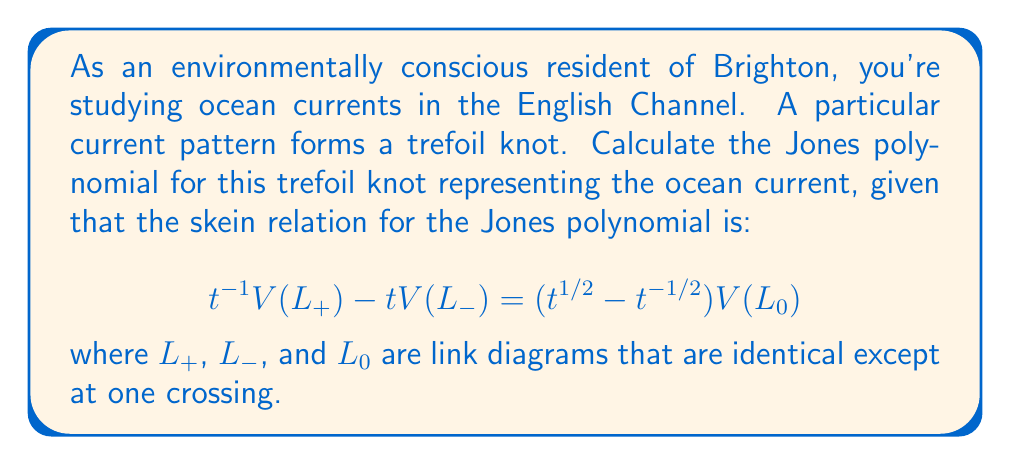What is the answer to this math problem? Let's calculate the Jones polynomial for the trefoil knot step-by-step:

1) First, we need to orient the trefoil knot. Let's consider the right-handed trefoil.

2) We'll use the skein relation repeatedly to simplify the knot:

   $$t^{-1}V(\text{trefoil}) - tV(\text{unknot}) = (t^{1/2} - t^{-1/2})V(\text{Hopf link})$$

3) We know that for the unknot, $V(\text{unknot}) = 1$

4) For the Hopf link, we can apply the skein relation again:

   $$t^{-1}V(\text{Hopf link}) - tV(\text{2 unlinked circles}) = (t^{1/2} - t^{-1/2})V(\text{unknot})$$

5) We know that $V(\text{2 unlinked circles}) = -t^{1/2} - t^{-3/2}$ and $V(\text{unknot}) = 1$

6) Substituting these into the equation from step 4:

   $$t^{-1}V(\text{Hopf link}) - t(-t^{1/2} - t^{-3/2}) = (t^{1/2} - t^{-1/2})$$

7) Solving for $V(\text{Hopf link})$:

   $$V(\text{Hopf link}) = -t^{5/2} - t^{1/2}$$

8) Now we can substitute this back into the equation from step 2:

   $$t^{-1}V(\text{trefoil}) - t = (t^{1/2} - t^{-1/2})(-t^{5/2} - t^{1/2})$$

9) Expanding the right side:

   $$t^{-1}V(\text{trefoil}) - t = -t^3 - t - t + t^{-1}$$

10) Solving for $V(\text{trefoil})$:

    $$V(\text{trefoil}) = t(-t^3 - t - t + t^{-1}) + t^2 = -t^4 - t^2 - t^2 + 1$$

11) Simplifying:

    $$V(\text{trefoil}) = -t^4 - 2t^2 + 1$$

This is the Jones polynomial for the right-handed trefoil knot.
Answer: $-t^4 - 2t^2 + 1$ 